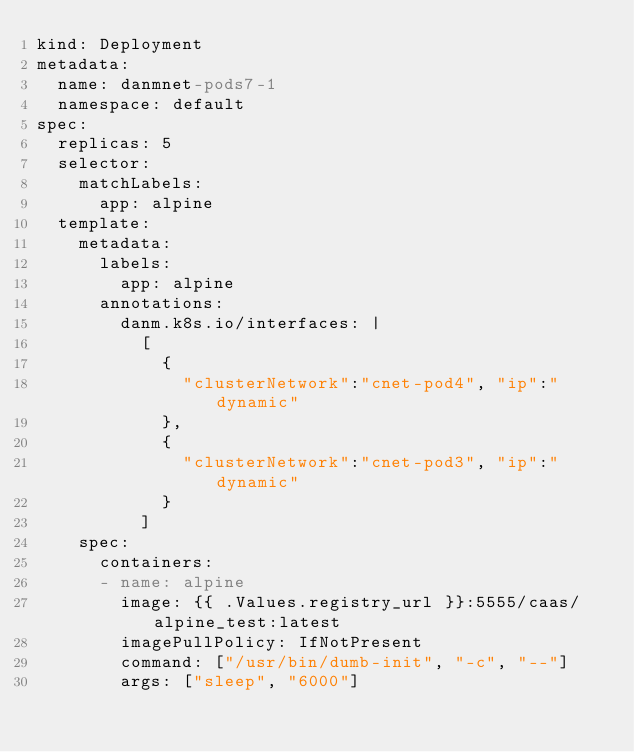<code> <loc_0><loc_0><loc_500><loc_500><_YAML_>kind: Deployment
metadata:
  name: danmnet-pods7-1
  namespace: default
spec:
  replicas: 5
  selector:
    matchLabels:
      app: alpine
  template:
    metadata:
      labels:
        app: alpine
      annotations:
        danm.k8s.io/interfaces: |
          [
            {
              "clusterNetwork":"cnet-pod4", "ip":"dynamic"
            },
            {
              "clusterNetwork":"cnet-pod3", "ip":"dynamic"
            }
          ]
    spec:
      containers:
      - name: alpine
        image: {{ .Values.registry_url }}:5555/caas/alpine_test:latest
        imagePullPolicy: IfNotPresent
        command: ["/usr/bin/dumb-init", "-c", "--"]
        args: ["sleep", "6000"]
</code> 